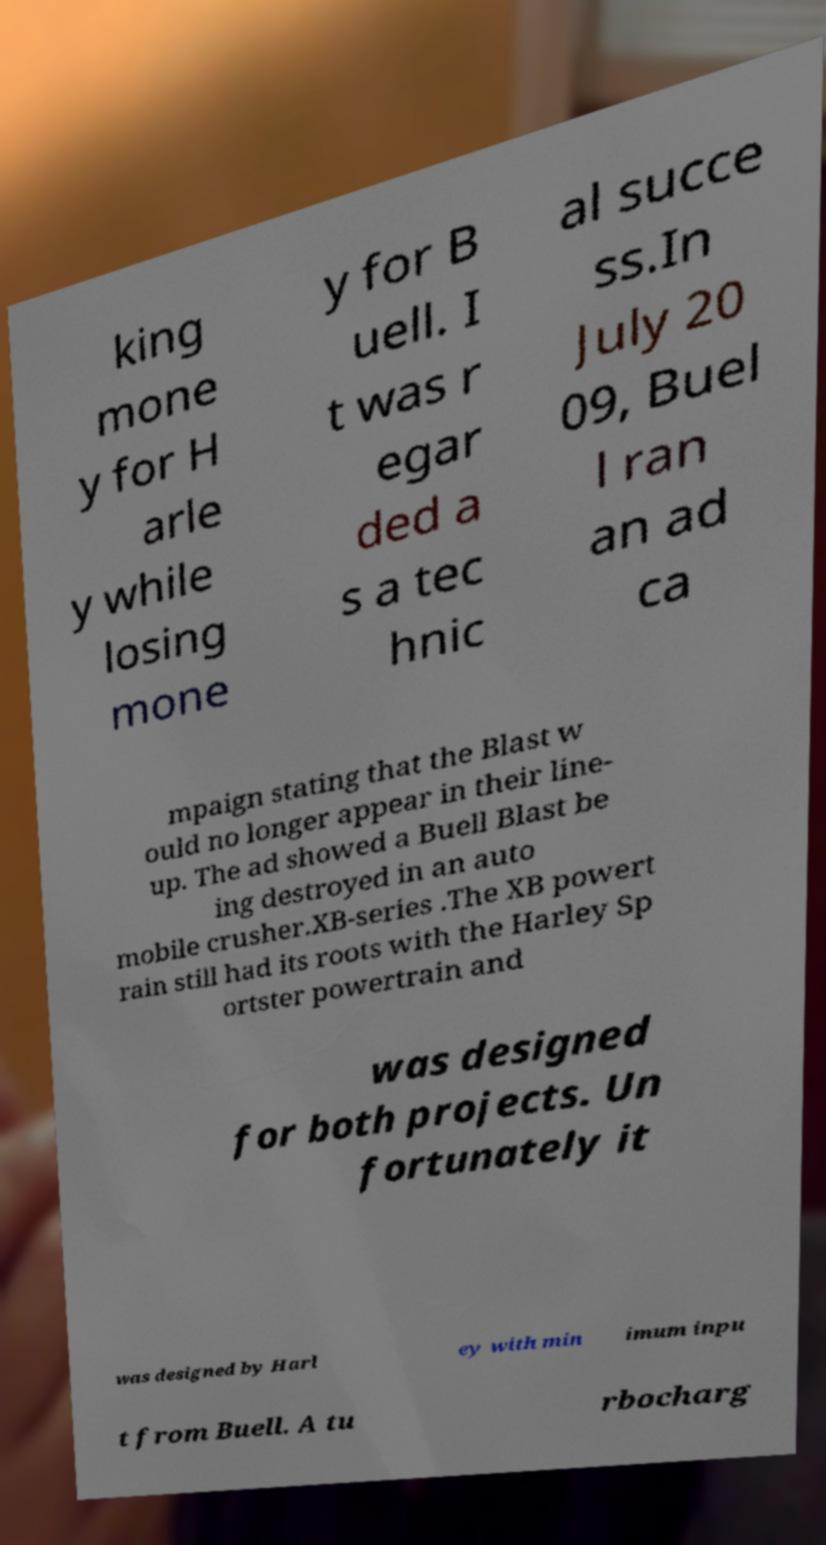For documentation purposes, I need the text within this image transcribed. Could you provide that? king mone y for H arle y while losing mone y for B uell. I t was r egar ded a s a tec hnic al succe ss.In July 20 09, Buel l ran an ad ca mpaign stating that the Blast w ould no longer appear in their line- up. The ad showed a Buell Blast be ing destroyed in an auto mobile crusher.XB-series .The XB powert rain still had its roots with the Harley Sp ortster powertrain and was designed for both projects. Un fortunately it was designed by Harl ey with min imum inpu t from Buell. A tu rbocharg 